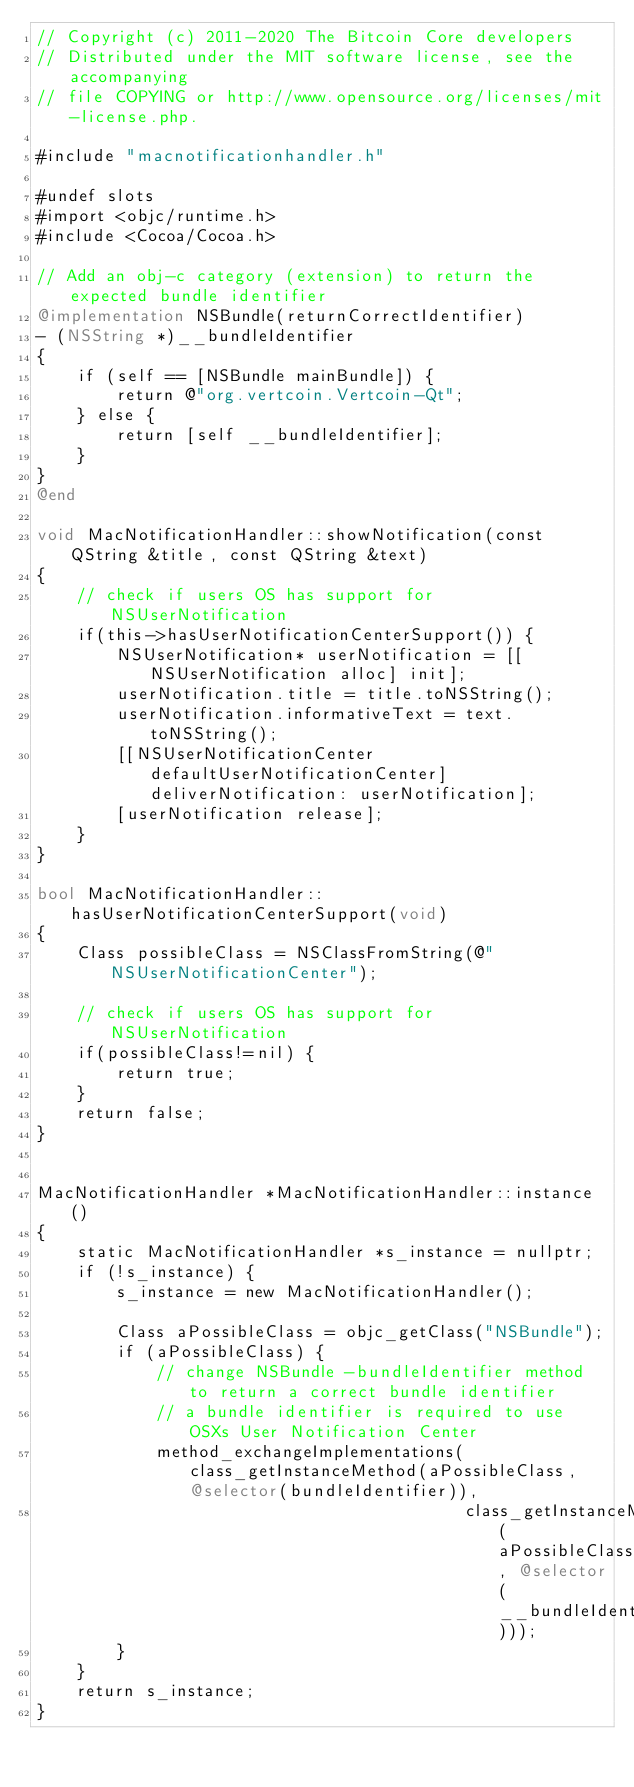<code> <loc_0><loc_0><loc_500><loc_500><_ObjectiveC_>// Copyright (c) 2011-2020 The Bitcoin Core developers
// Distributed under the MIT software license, see the accompanying
// file COPYING or http://www.opensource.org/licenses/mit-license.php.

#include "macnotificationhandler.h"

#undef slots
#import <objc/runtime.h>
#include <Cocoa/Cocoa.h>

// Add an obj-c category (extension) to return the expected bundle identifier
@implementation NSBundle(returnCorrectIdentifier)
- (NSString *)__bundleIdentifier
{
    if (self == [NSBundle mainBundle]) {
        return @"org.vertcoin.Vertcoin-Qt";
    } else {
        return [self __bundleIdentifier];
    }
}
@end

void MacNotificationHandler::showNotification(const QString &title, const QString &text)
{
    // check if users OS has support for NSUserNotification
    if(this->hasUserNotificationCenterSupport()) {
        NSUserNotification* userNotification = [[NSUserNotification alloc] init];
        userNotification.title = title.toNSString();
        userNotification.informativeText = text.toNSString();
        [[NSUserNotificationCenter defaultUserNotificationCenter] deliverNotification: userNotification];
        [userNotification release];
    }
}

bool MacNotificationHandler::hasUserNotificationCenterSupport(void)
{
    Class possibleClass = NSClassFromString(@"NSUserNotificationCenter");

    // check if users OS has support for NSUserNotification
    if(possibleClass!=nil) {
        return true;
    }
    return false;
}


MacNotificationHandler *MacNotificationHandler::instance()
{
    static MacNotificationHandler *s_instance = nullptr;
    if (!s_instance) {
        s_instance = new MacNotificationHandler();

        Class aPossibleClass = objc_getClass("NSBundle");
        if (aPossibleClass) {
            // change NSBundle -bundleIdentifier method to return a correct bundle identifier
            // a bundle identifier is required to use OSXs User Notification Center
            method_exchangeImplementations(class_getInstanceMethod(aPossibleClass, @selector(bundleIdentifier)),
                                           class_getInstanceMethod(aPossibleClass, @selector(__bundleIdentifier)));
        }
    }
    return s_instance;
}
</code> 